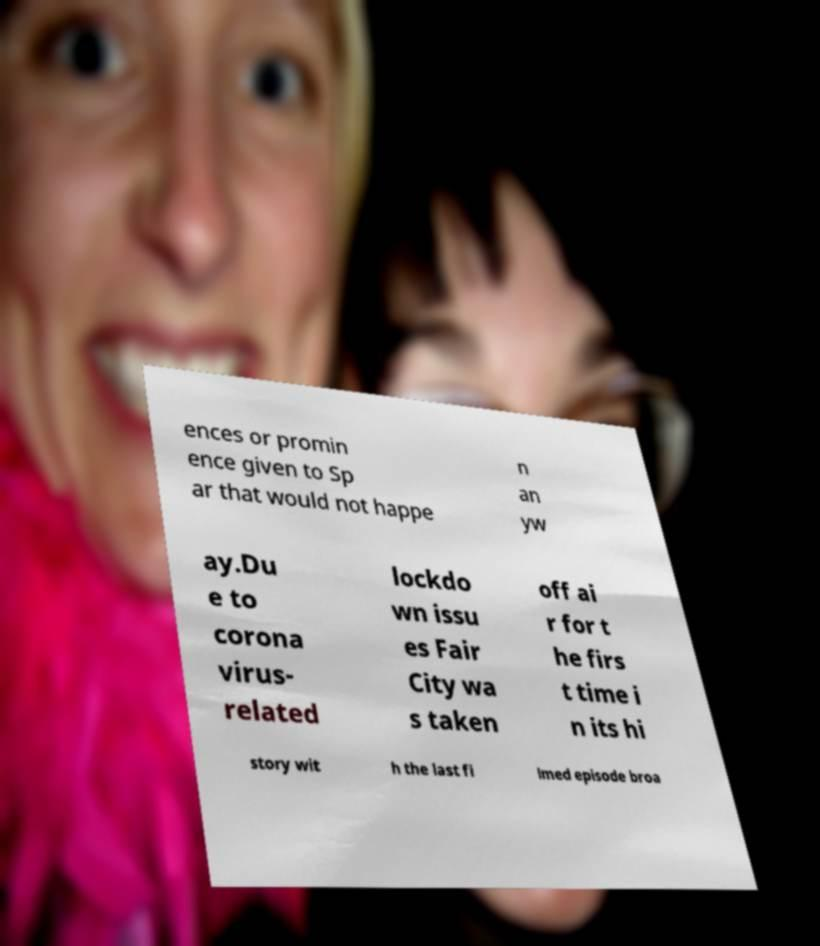For documentation purposes, I need the text within this image transcribed. Could you provide that? ences or promin ence given to Sp ar that would not happe n an yw ay.Du e to corona virus- related lockdo wn issu es Fair City wa s taken off ai r for t he firs t time i n its hi story wit h the last fi lmed episode broa 